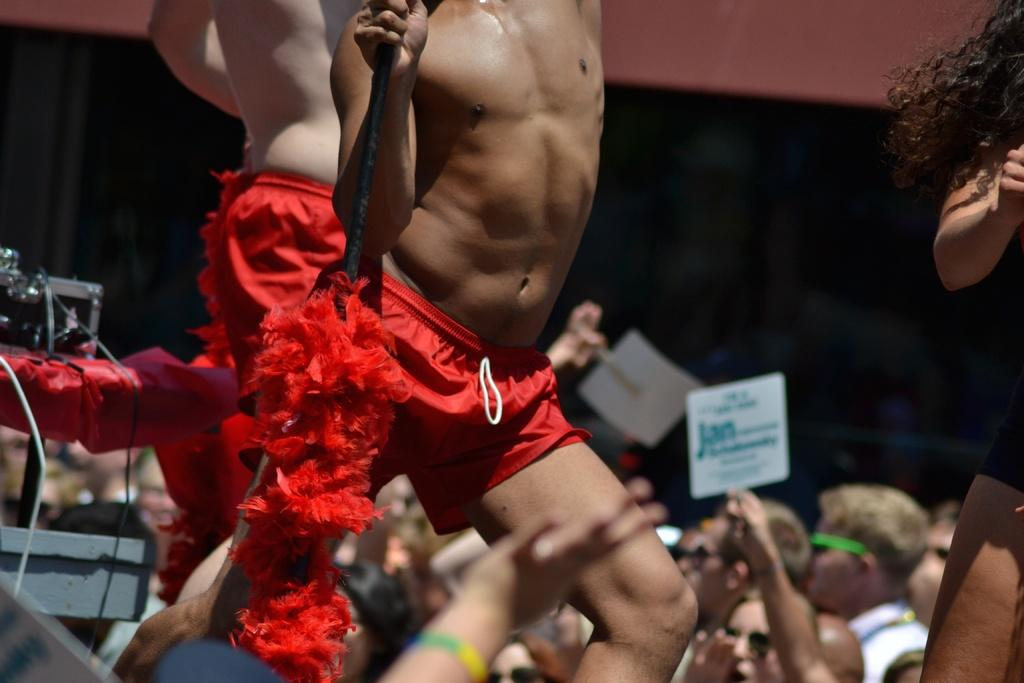How many people are in the image? There are two men in the image. What are the men doing in the image? The men are dancing in the image. What are the men wearing? The men are wearing red shorts in the image. What can be seen on the table in the image? There is a music setup on a table in the image. What is visible at the bottom of the image? There is a crowd at the bottom of the image. What type of jewel is the man wearing on his neck in the image? There is no jewel visible on the men's necks in the image. How does the poison affect the men while they are dancing in the image? There is no mention of poison in the image, and the men appear to be dancing without any visible issues. 